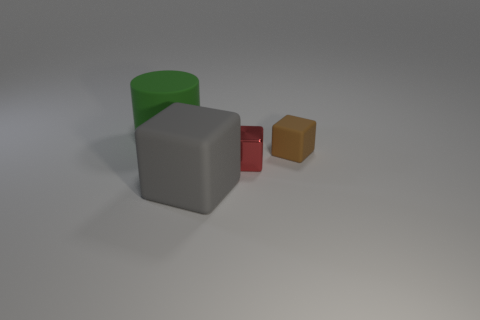Add 2 large gray objects. How many objects exist? 6 Subtract all cylinders. How many objects are left? 3 Add 4 big objects. How many big objects exist? 6 Subtract 0 green balls. How many objects are left? 4 Subtract all big green things. Subtract all brown rubber cubes. How many objects are left? 2 Add 2 red shiny cubes. How many red shiny cubes are left? 3 